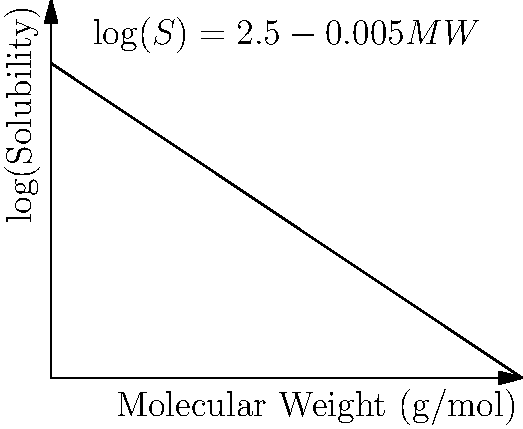As a pharmacist providing essential pharmaceutical ingredients, you're researching a new drug compound. Given the equation $\log(S) = 2.5 - 0.005MW$, where $S$ is the solubility in mg/mL and $MW$ is the molecular weight in g/mol, predict the solubility of a drug with a molecular weight of 300 g/mol. To solve this problem, we'll follow these steps:

1) We're given the equation: $\log(S) = 2.5 - 0.005MW$

2) We know the molecular weight (MW) is 300 g/mol. Let's substitute this into the equation:

   $\log(S) = 2.5 - 0.005(300)$

3) Let's calculate the right side of the equation:
   
   $\log(S) = 2.5 - 1.5 = 1$

4) Now we have:

   $\log(S) = 1$

5) To find S, we need to apply the inverse function of log (which is 10^x):

   $S = 10^1 = 10$ mg/mL

Therefore, the predicted solubility of the drug is 10 mg/mL.
Answer: 10 mg/mL 